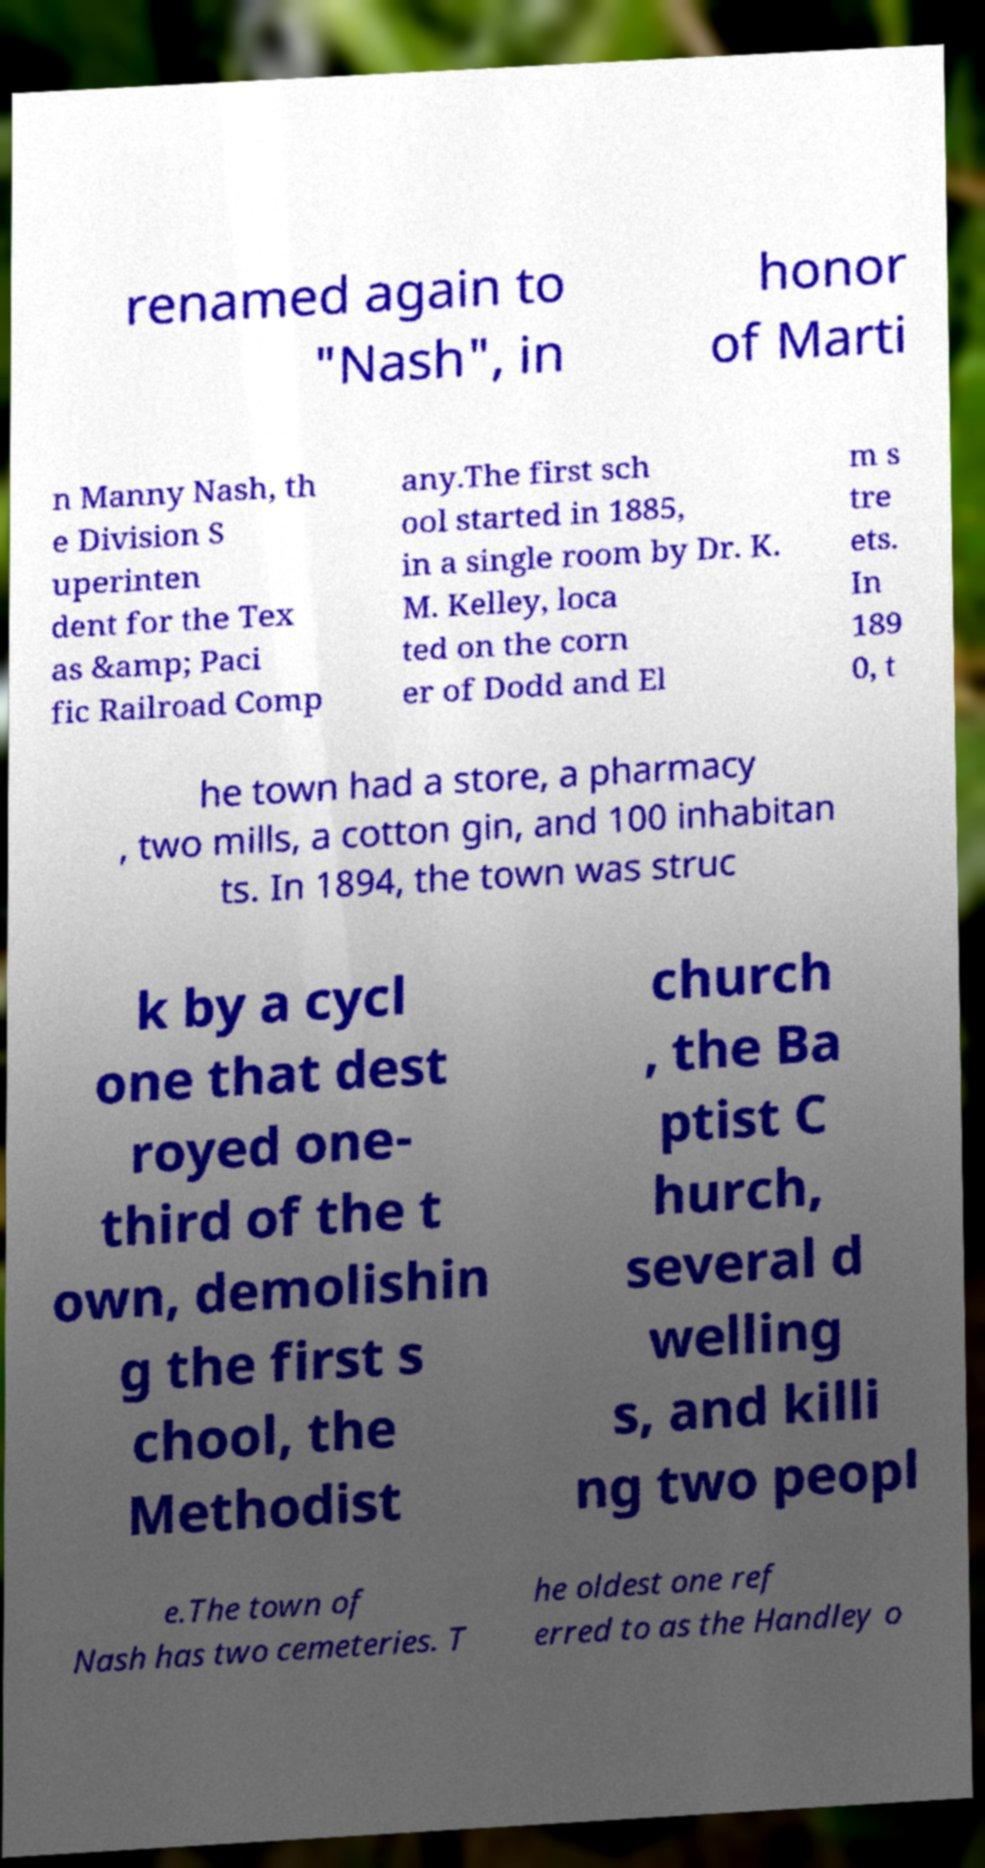Could you assist in decoding the text presented in this image and type it out clearly? renamed again to "Nash", in honor of Marti n Manny Nash, th e Division S uperinten dent for the Tex as &amp; Paci fic Railroad Comp any.The first sch ool started in 1885, in a single room by Dr. K. M. Kelley, loca ted on the corn er of Dodd and El m s tre ets. In 189 0, t he town had a store, a pharmacy , two mills, a cotton gin, and 100 inhabitan ts. In 1894, the town was struc k by a cycl one that dest royed one- third of the t own, demolishin g the first s chool, the Methodist church , the Ba ptist C hurch, several d welling s, and killi ng two peopl e.The town of Nash has two cemeteries. T he oldest one ref erred to as the Handley o 